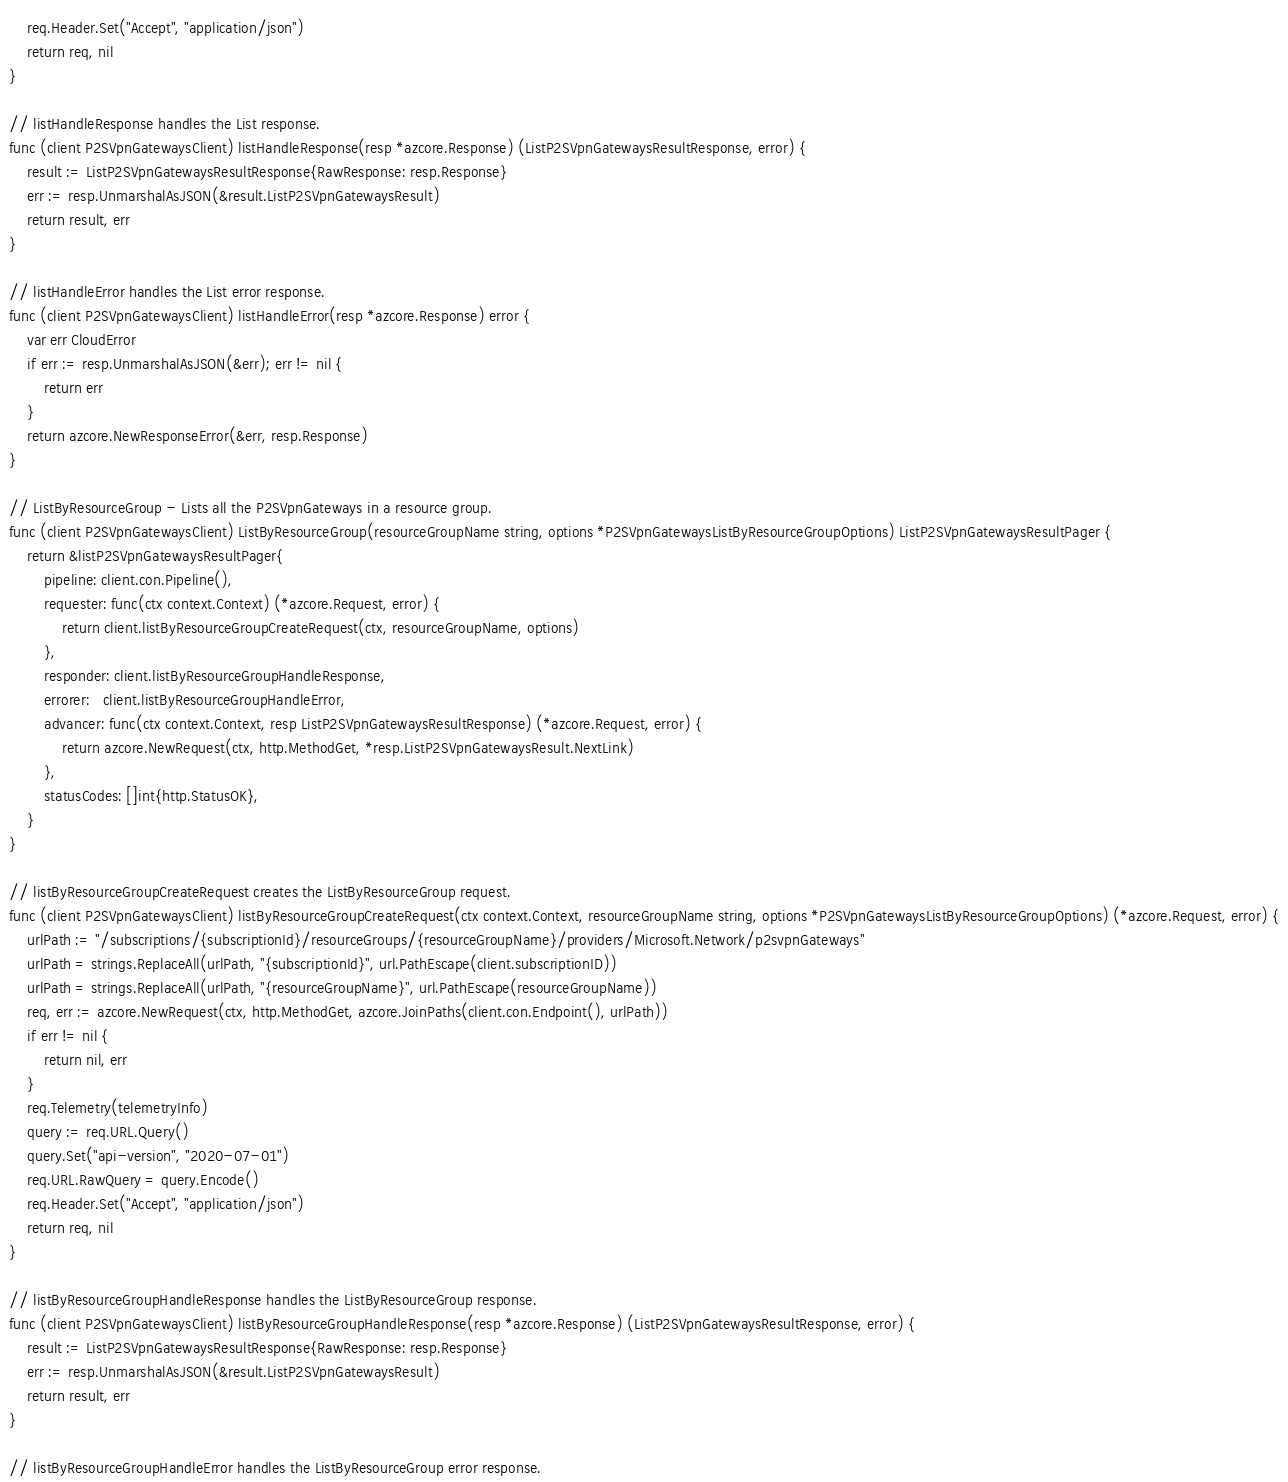<code> <loc_0><loc_0><loc_500><loc_500><_Go_>	req.Header.Set("Accept", "application/json")
	return req, nil
}

// listHandleResponse handles the List response.
func (client P2SVpnGatewaysClient) listHandleResponse(resp *azcore.Response) (ListP2SVpnGatewaysResultResponse, error) {
	result := ListP2SVpnGatewaysResultResponse{RawResponse: resp.Response}
	err := resp.UnmarshalAsJSON(&result.ListP2SVpnGatewaysResult)
	return result, err
}

// listHandleError handles the List error response.
func (client P2SVpnGatewaysClient) listHandleError(resp *azcore.Response) error {
	var err CloudError
	if err := resp.UnmarshalAsJSON(&err); err != nil {
		return err
	}
	return azcore.NewResponseError(&err, resp.Response)
}

// ListByResourceGroup - Lists all the P2SVpnGateways in a resource group.
func (client P2SVpnGatewaysClient) ListByResourceGroup(resourceGroupName string, options *P2SVpnGatewaysListByResourceGroupOptions) ListP2SVpnGatewaysResultPager {
	return &listP2SVpnGatewaysResultPager{
		pipeline: client.con.Pipeline(),
		requester: func(ctx context.Context) (*azcore.Request, error) {
			return client.listByResourceGroupCreateRequest(ctx, resourceGroupName, options)
		},
		responder: client.listByResourceGroupHandleResponse,
		errorer:   client.listByResourceGroupHandleError,
		advancer: func(ctx context.Context, resp ListP2SVpnGatewaysResultResponse) (*azcore.Request, error) {
			return azcore.NewRequest(ctx, http.MethodGet, *resp.ListP2SVpnGatewaysResult.NextLink)
		},
		statusCodes: []int{http.StatusOK},
	}
}

// listByResourceGroupCreateRequest creates the ListByResourceGroup request.
func (client P2SVpnGatewaysClient) listByResourceGroupCreateRequest(ctx context.Context, resourceGroupName string, options *P2SVpnGatewaysListByResourceGroupOptions) (*azcore.Request, error) {
	urlPath := "/subscriptions/{subscriptionId}/resourceGroups/{resourceGroupName}/providers/Microsoft.Network/p2svpnGateways"
	urlPath = strings.ReplaceAll(urlPath, "{subscriptionId}", url.PathEscape(client.subscriptionID))
	urlPath = strings.ReplaceAll(urlPath, "{resourceGroupName}", url.PathEscape(resourceGroupName))
	req, err := azcore.NewRequest(ctx, http.MethodGet, azcore.JoinPaths(client.con.Endpoint(), urlPath))
	if err != nil {
		return nil, err
	}
	req.Telemetry(telemetryInfo)
	query := req.URL.Query()
	query.Set("api-version", "2020-07-01")
	req.URL.RawQuery = query.Encode()
	req.Header.Set("Accept", "application/json")
	return req, nil
}

// listByResourceGroupHandleResponse handles the ListByResourceGroup response.
func (client P2SVpnGatewaysClient) listByResourceGroupHandleResponse(resp *azcore.Response) (ListP2SVpnGatewaysResultResponse, error) {
	result := ListP2SVpnGatewaysResultResponse{RawResponse: resp.Response}
	err := resp.UnmarshalAsJSON(&result.ListP2SVpnGatewaysResult)
	return result, err
}

// listByResourceGroupHandleError handles the ListByResourceGroup error response.</code> 